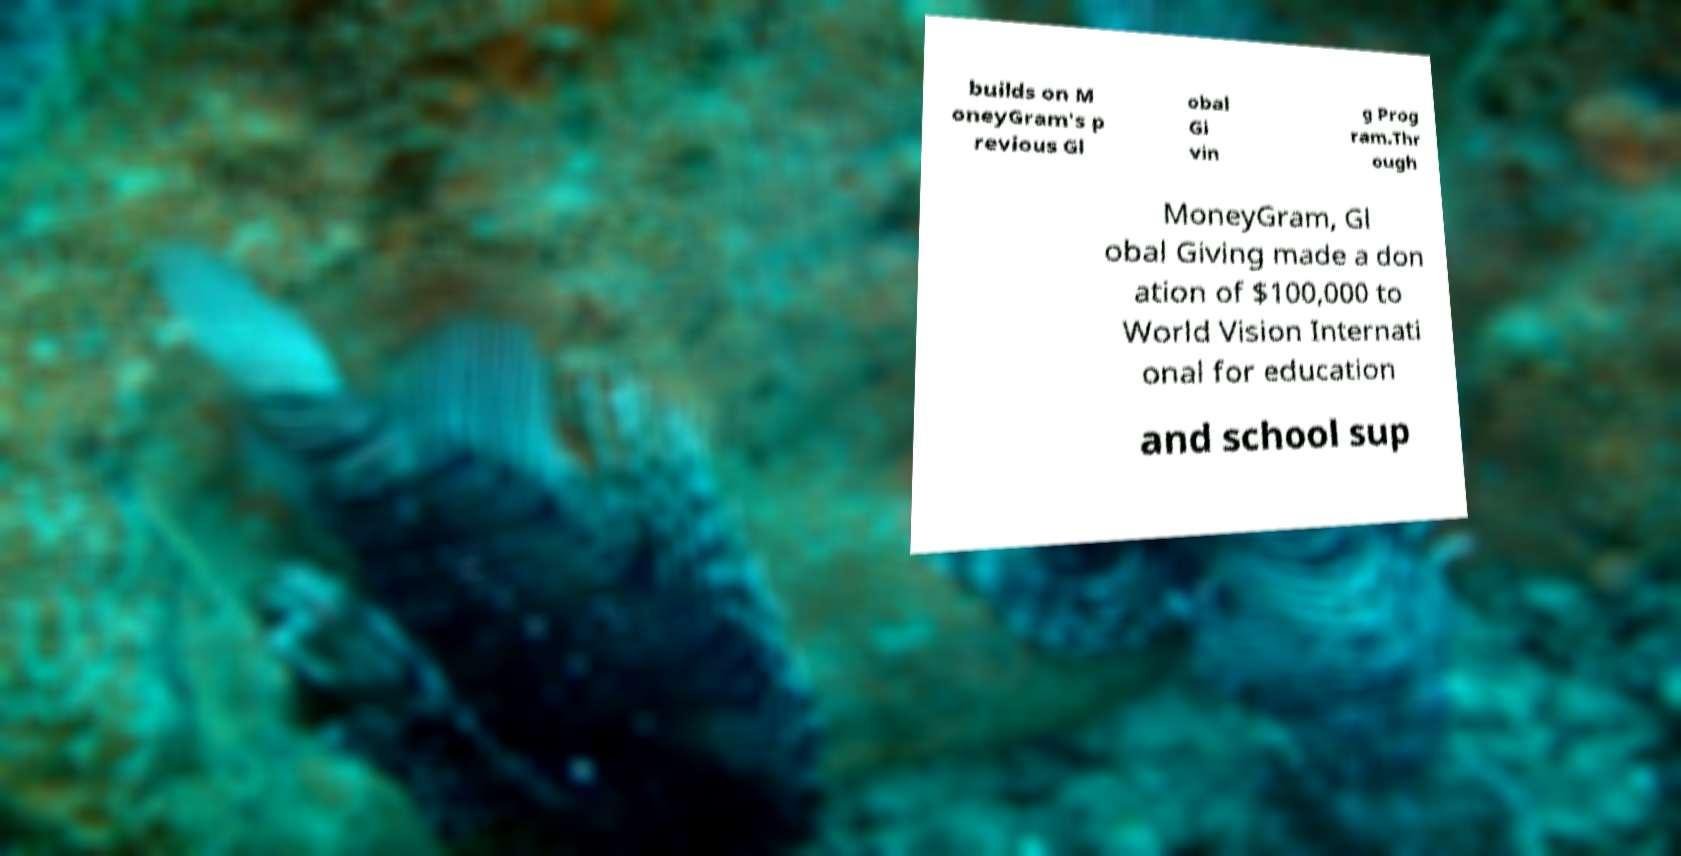Please read and relay the text visible in this image. What does it say? builds on M oneyGram's p revious Gl obal Gi vin g Prog ram.Thr ough MoneyGram, Gl obal Giving made a don ation of $100,000 to World Vision Internati onal for education and school sup 